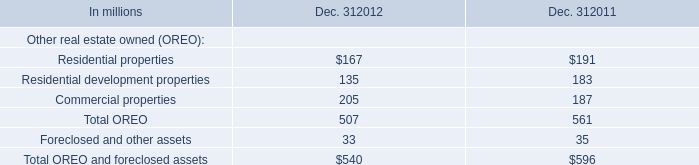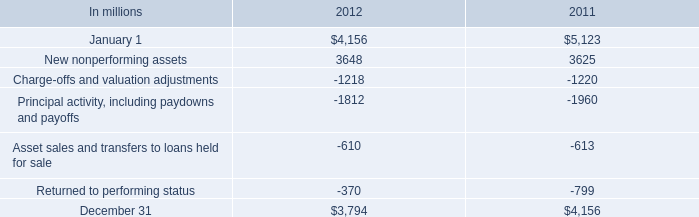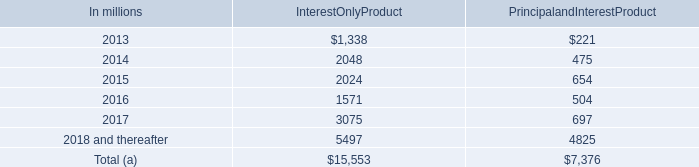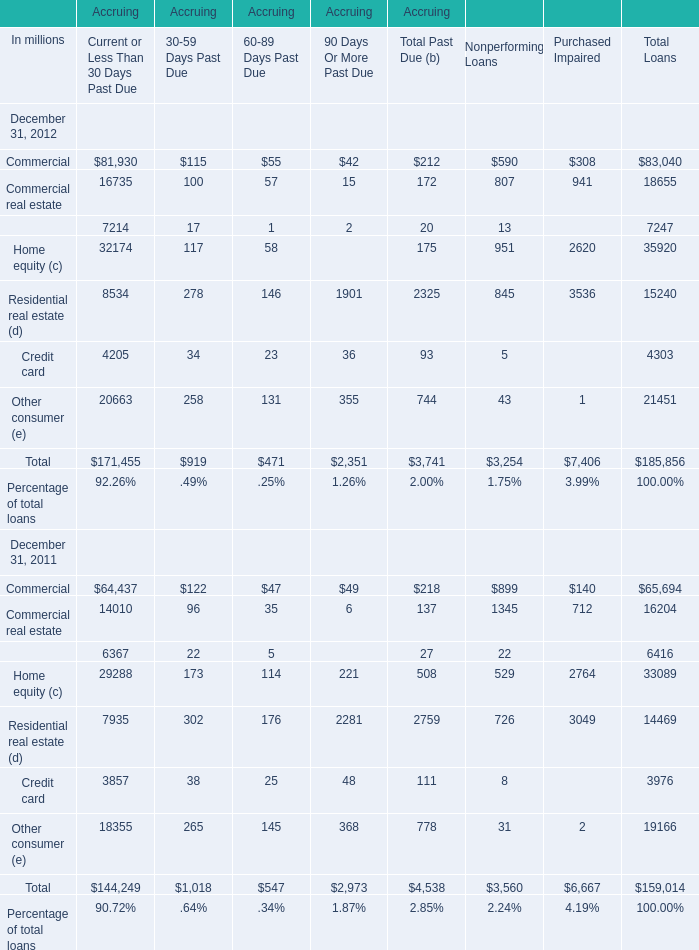What was the average of the Home equity and Residential real estate in the years where Commercial is positive? (in million) 
Computations: ((32174 + 8534) / 2)
Answer: 20354.0. 